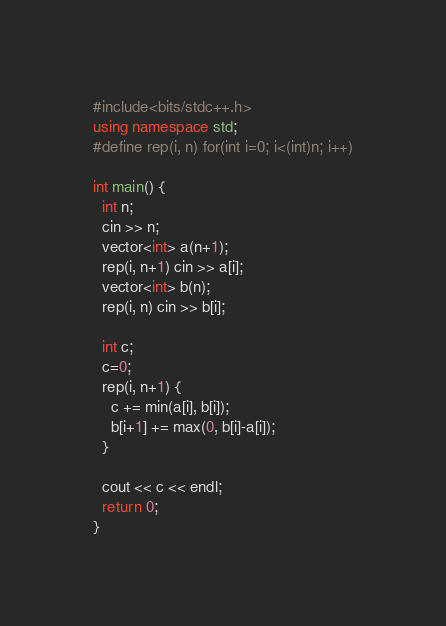Convert code to text. <code><loc_0><loc_0><loc_500><loc_500><_C++_>#include<bits/stdc++.h>
using namespace std;
#define rep(i, n) for(int i=0; i<(int)n; i++)

int main() {
  int n;
  cin >> n;
  vector<int> a(n+1);
  rep(i, n+1) cin >> a[i];
  vector<int> b(n);
  rep(i, n) cin >> b[i];
  
  int c;
  c=0;
  rep(i, n+1) {
   	c += min(a[i], b[i]);
    b[i+1] += max(0, b[i]-a[i]);  
  }
  
  cout << c << endl;
  return 0;
}</code> 